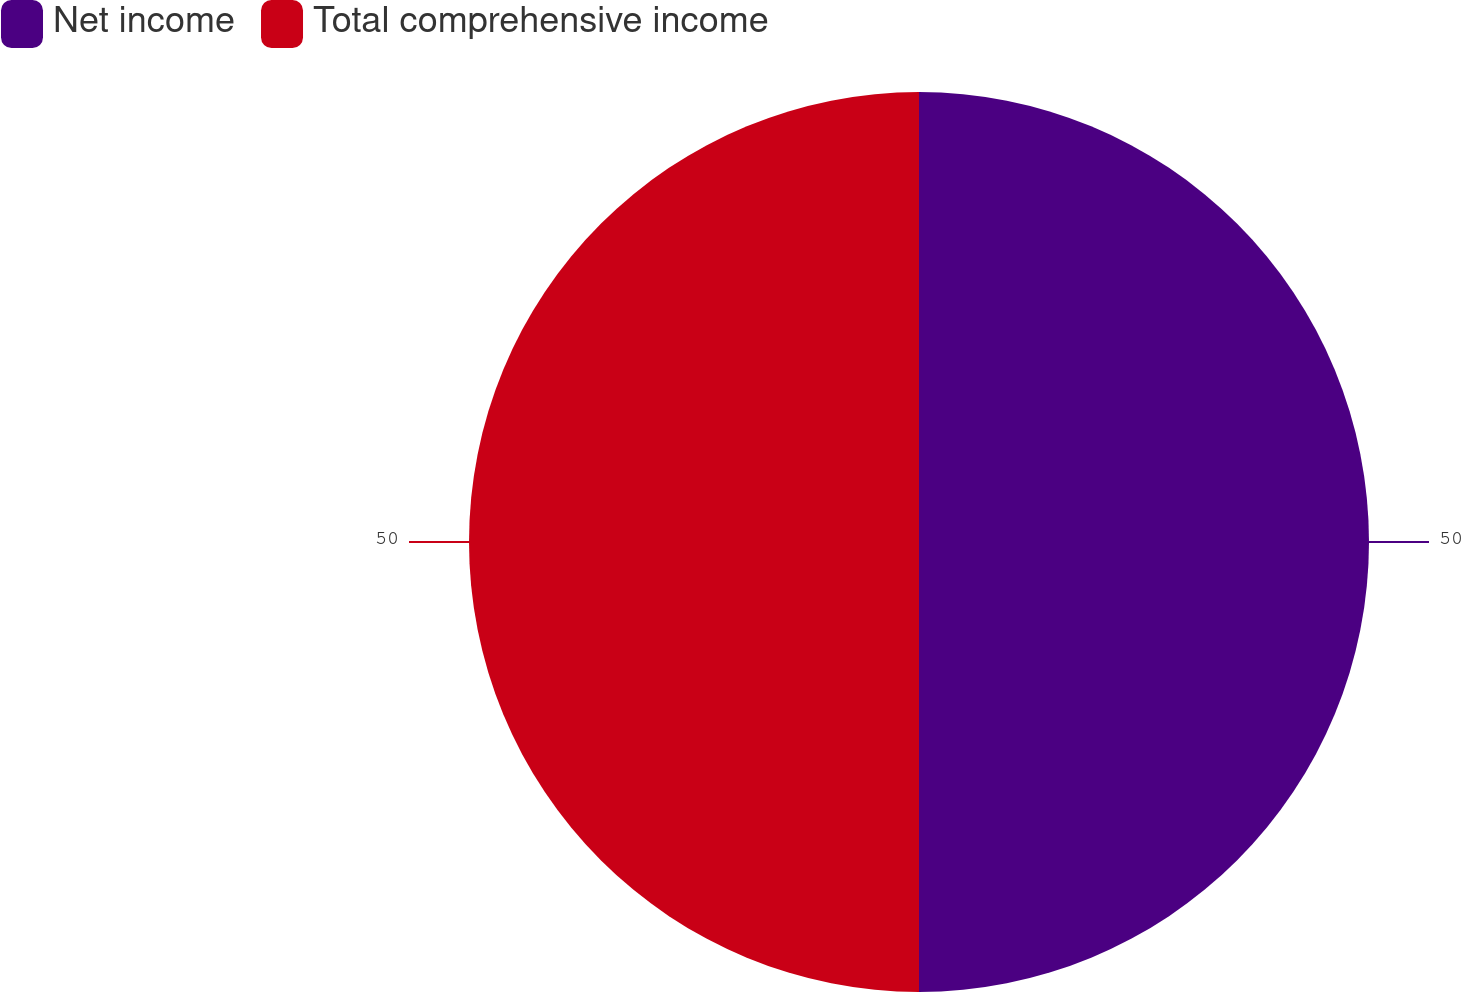Convert chart. <chart><loc_0><loc_0><loc_500><loc_500><pie_chart><fcel>Net income<fcel>Total comprehensive income<nl><fcel>50.0%<fcel>50.0%<nl></chart> 